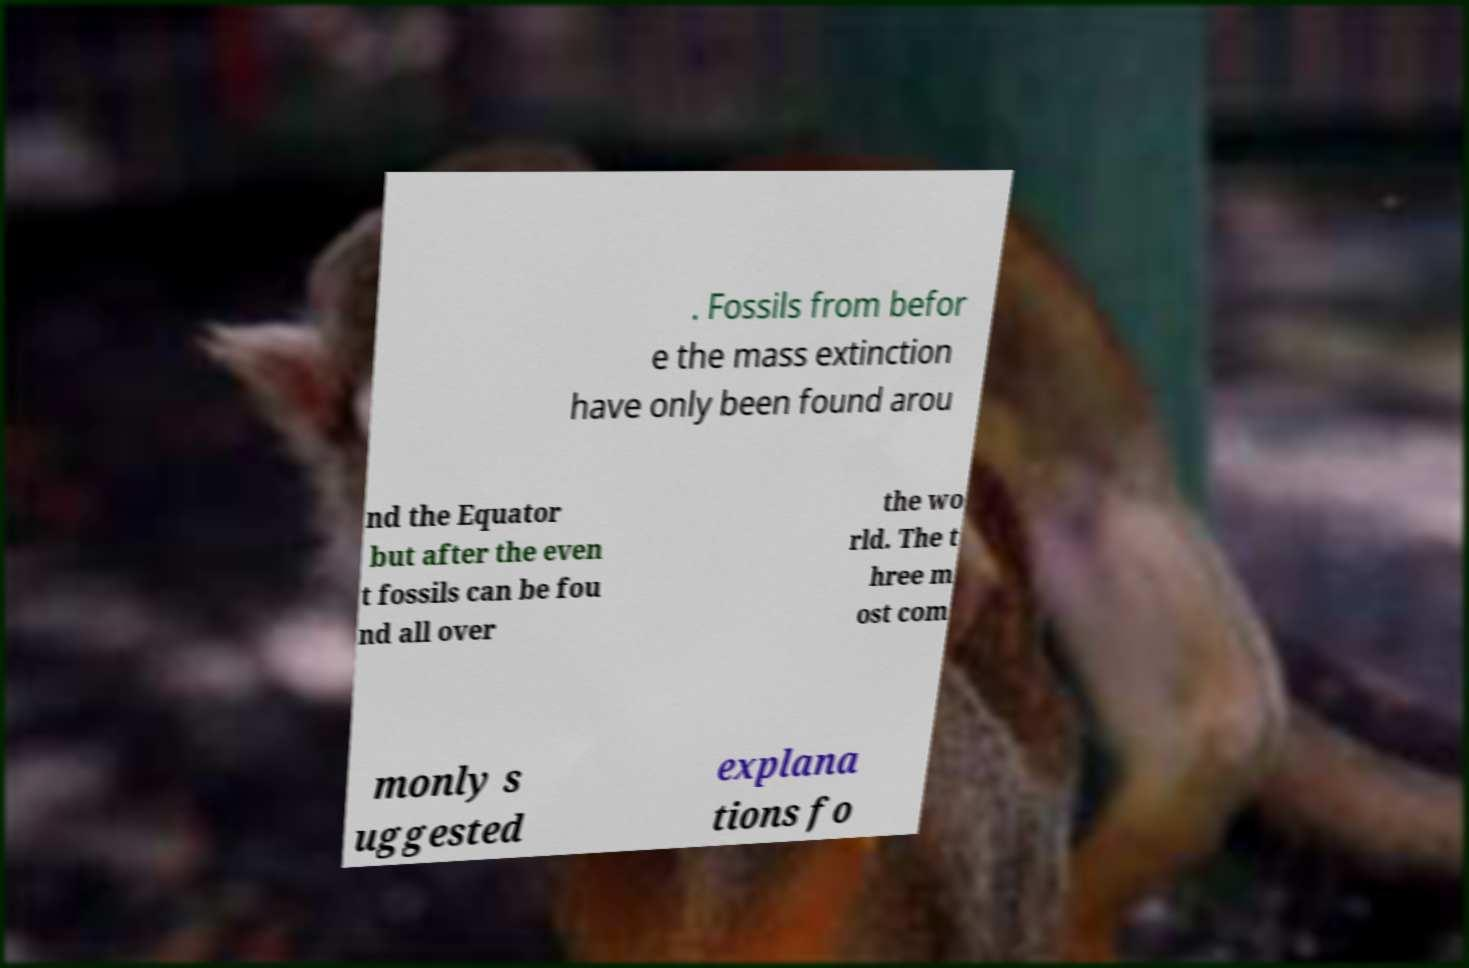Please identify and transcribe the text found in this image. . Fossils from befor e the mass extinction have only been found arou nd the Equator but after the even t fossils can be fou nd all over the wo rld. The t hree m ost com monly s uggested explana tions fo 